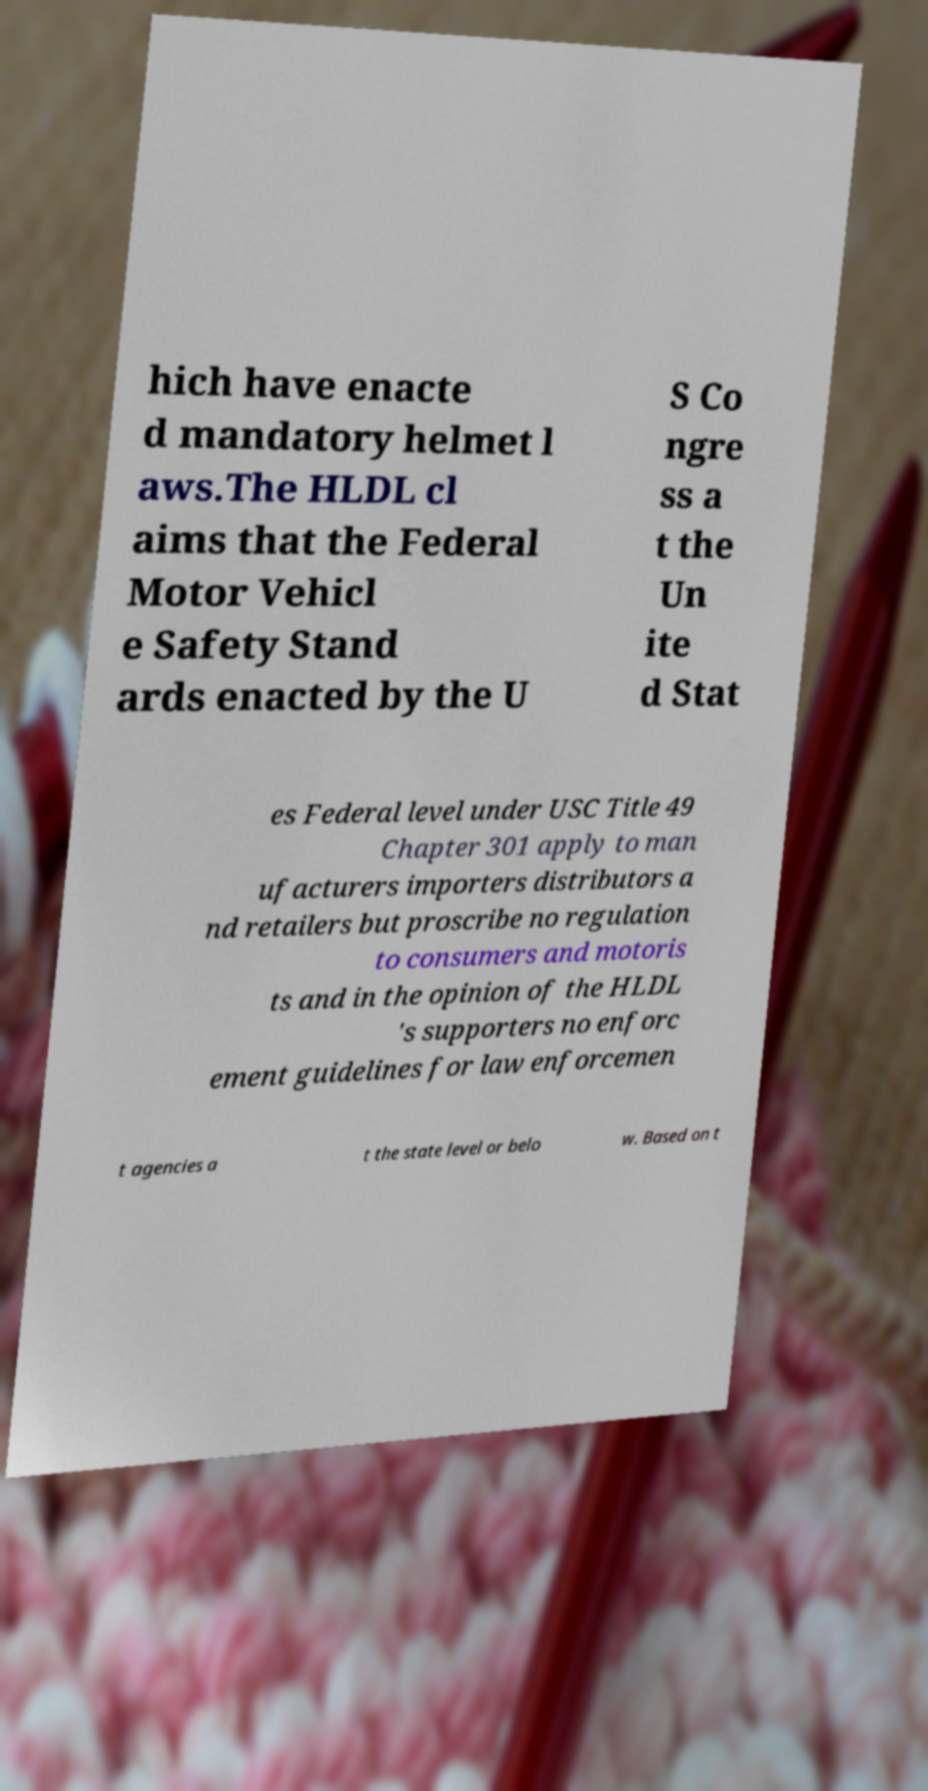For documentation purposes, I need the text within this image transcribed. Could you provide that? hich have enacte d mandatory helmet l aws.The HLDL cl aims that the Federal Motor Vehicl e Safety Stand ards enacted by the U S Co ngre ss a t the Un ite d Stat es Federal level under USC Title 49 Chapter 301 apply to man ufacturers importers distributors a nd retailers but proscribe no regulation to consumers and motoris ts and in the opinion of the HLDL 's supporters no enforc ement guidelines for law enforcemen t agencies a t the state level or belo w. Based on t 